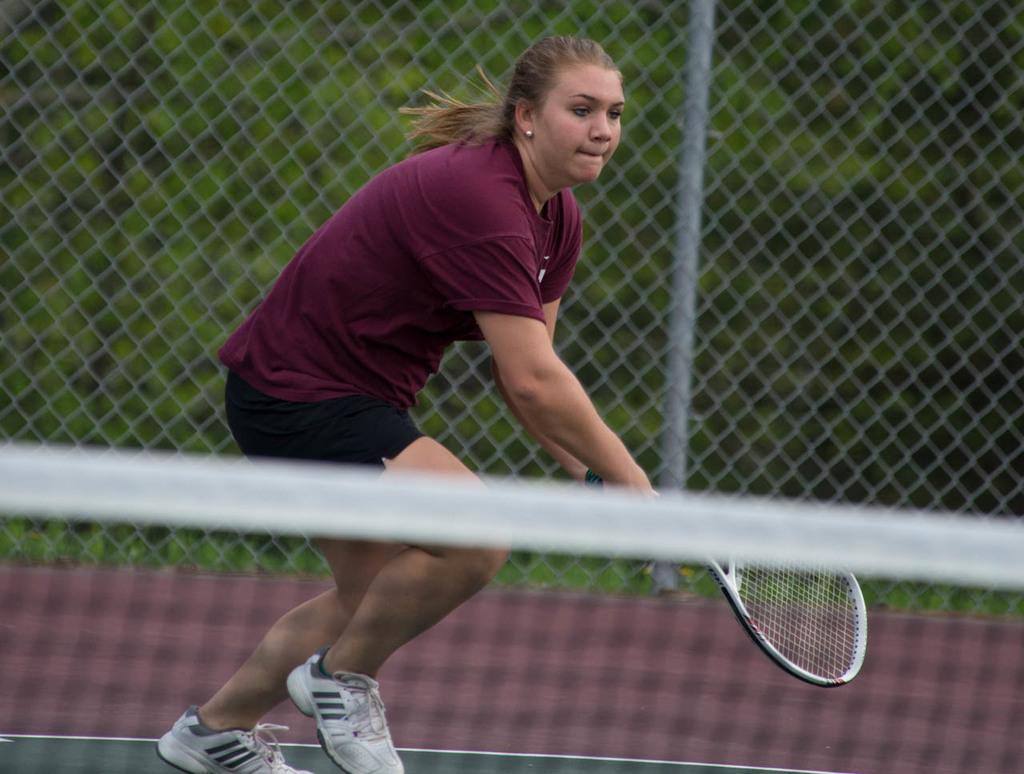Please provide a concise description of this image. There is a woman in brown color t-shirt holding a bat and playing on the court. In front of her, there is a net. In the background, there is fencing. Outside this fencing, there are trees. And the background is green in color. 